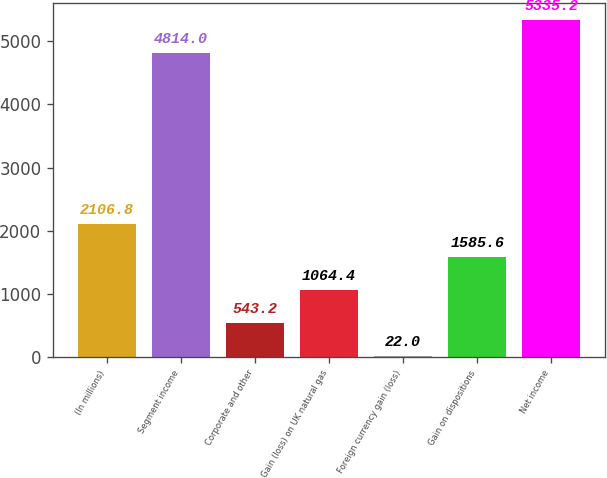<chart> <loc_0><loc_0><loc_500><loc_500><bar_chart><fcel>(In millions)<fcel>Segment income<fcel>Corporate and other<fcel>Gain (loss) on UK natural gas<fcel>Foreign currency gain (loss)<fcel>Gain on dispositions<fcel>Net income<nl><fcel>2106.8<fcel>4814<fcel>543.2<fcel>1064.4<fcel>22<fcel>1585.6<fcel>5335.2<nl></chart> 